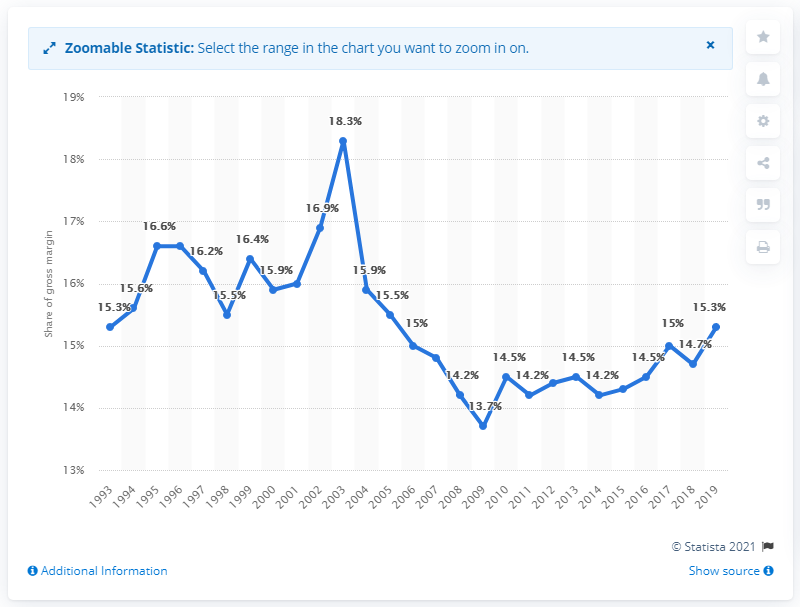Specify some key components in this picture. In 2019, the gross margin as a percentage of sales of groceries and related products in the U.S. wholesale industry was 15.3%. 